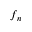<formula> <loc_0><loc_0><loc_500><loc_500>f _ { n }</formula> 